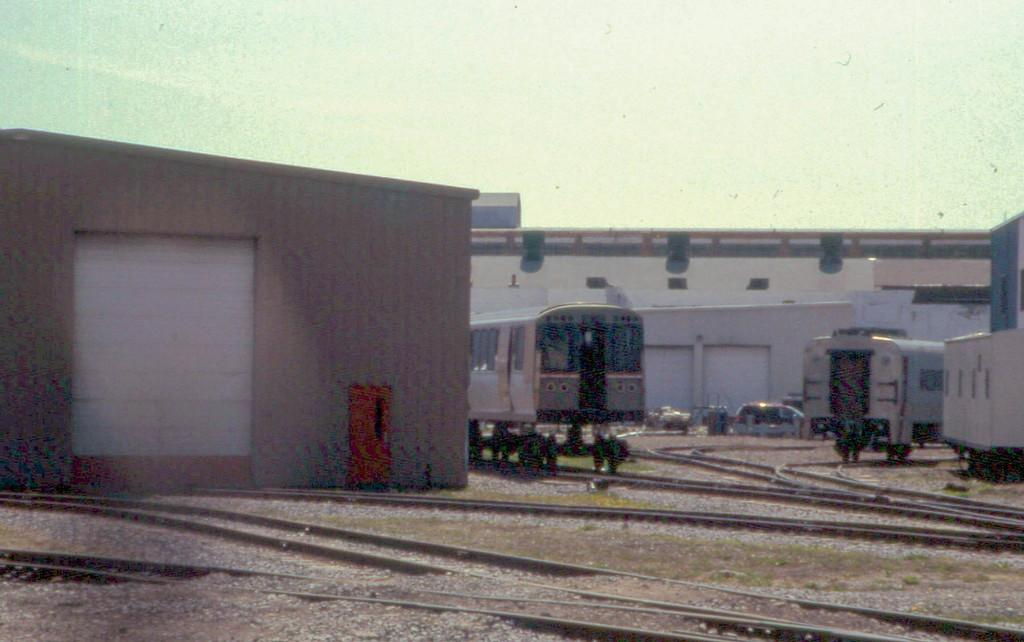What type of structures are visible in the image? There are sheds and train carriages in the image. What is the purpose of the railway track in the image? The railway track is likely used for trains to travel on. Can you describe the setting of the image? The image features sheds, train carriages, and a railway track, which suggests a railway or train yard setting. What type of van can be seen parked next to the sheds in the image? There is no van present in the image; it only features sheds, train carriages, and a railway track. 